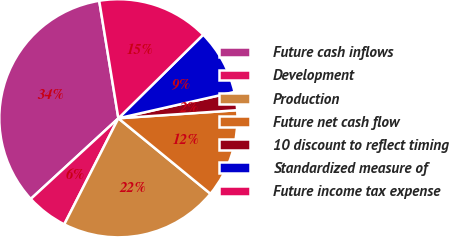Convert chart to OTSL. <chart><loc_0><loc_0><loc_500><loc_500><pie_chart><fcel>Future cash inflows<fcel>Development<fcel>Production<fcel>Future net cash flow<fcel>10 discount to reflect timing<fcel>Standardized measure of<fcel>Future income tax expense<nl><fcel>34.27%<fcel>5.65%<fcel>21.58%<fcel>12.01%<fcel>2.47%<fcel>8.83%<fcel>15.19%<nl></chart> 